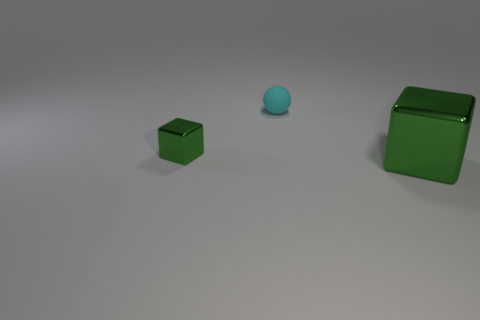What color is the large object that is the same shape as the tiny green object? The large object that shares the same cubic shape as the tiny green one is also green, showcasing the consistency of color among objects with the same shape in this image. 